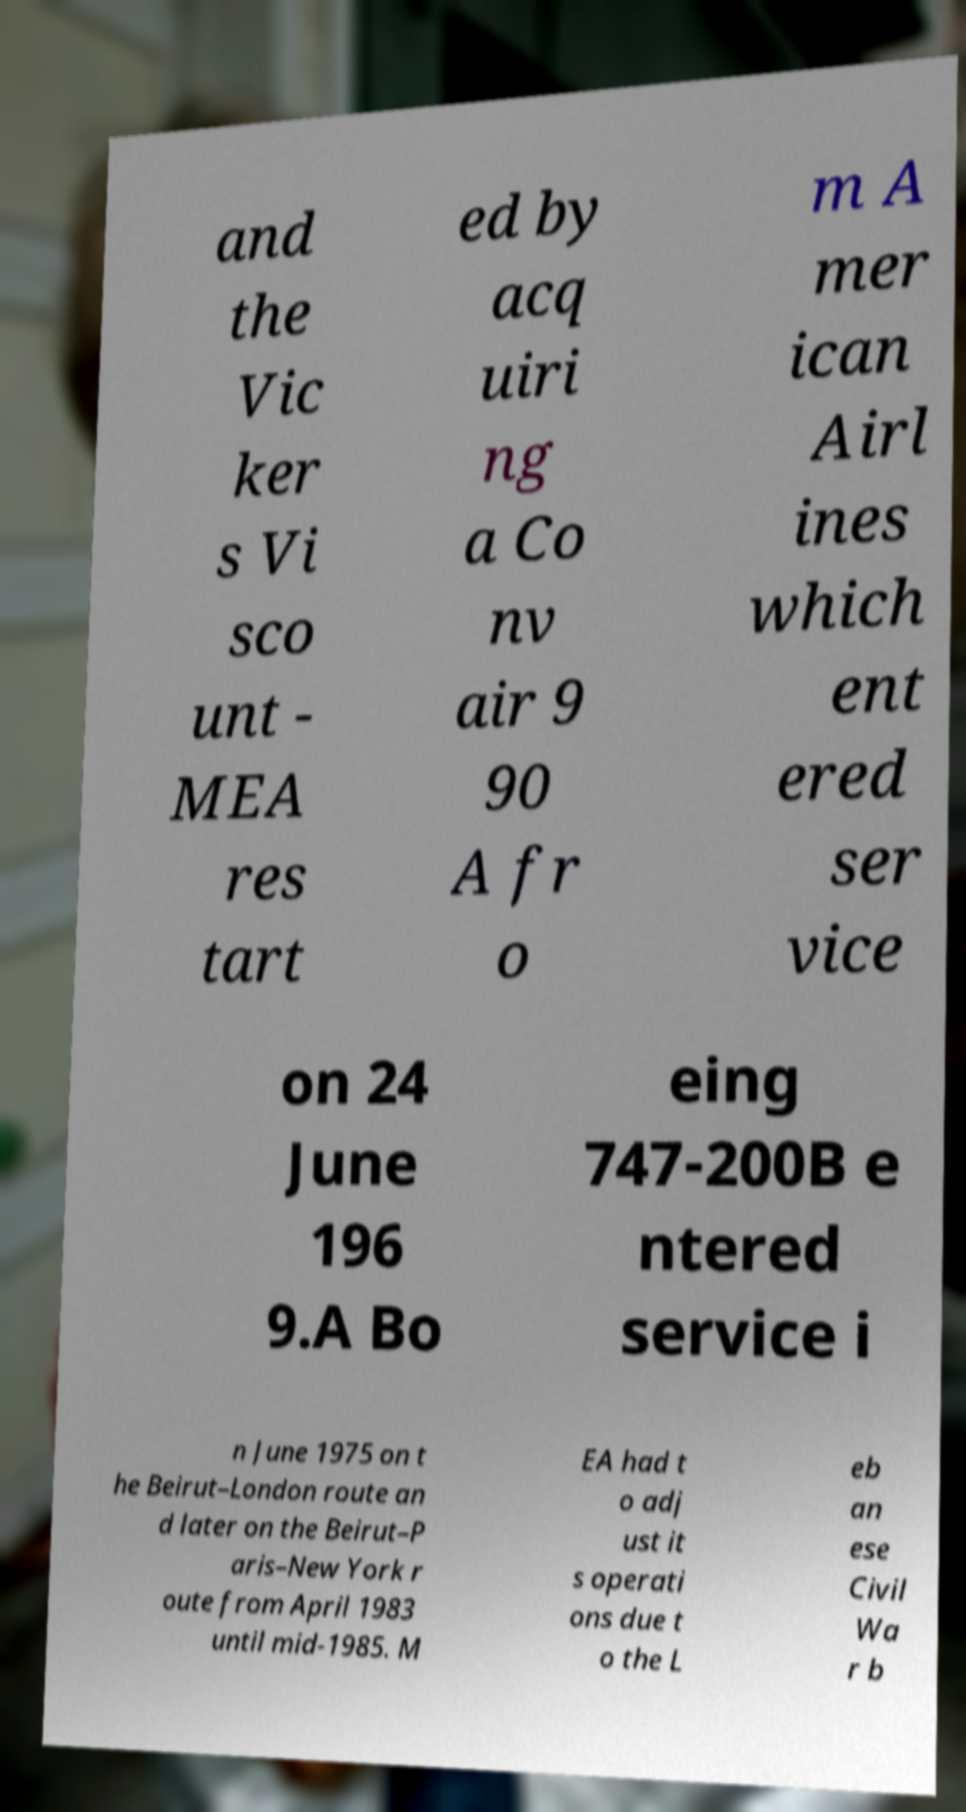Can you accurately transcribe the text from the provided image for me? and the Vic ker s Vi sco unt - MEA res tart ed by acq uiri ng a Co nv air 9 90 A fr o m A mer ican Airl ines which ent ered ser vice on 24 June 196 9.A Bo eing 747-200B e ntered service i n June 1975 on t he Beirut–London route an d later on the Beirut–P aris–New York r oute from April 1983 until mid-1985. M EA had t o adj ust it s operati ons due t o the L eb an ese Civil Wa r b 